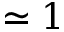<formula> <loc_0><loc_0><loc_500><loc_500>\simeq 1</formula> 